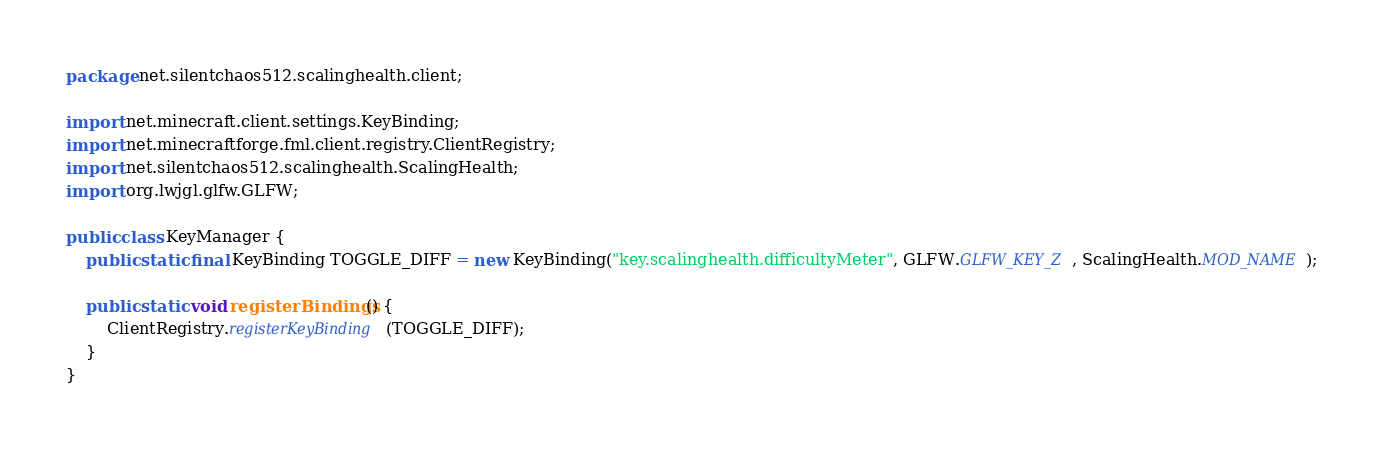Convert code to text. <code><loc_0><loc_0><loc_500><loc_500><_Java_>package net.silentchaos512.scalinghealth.client;

import net.minecraft.client.settings.KeyBinding;
import net.minecraftforge.fml.client.registry.ClientRegistry;
import net.silentchaos512.scalinghealth.ScalingHealth;
import org.lwjgl.glfw.GLFW;

public class KeyManager {
    public static final KeyBinding TOGGLE_DIFF = new KeyBinding("key.scalinghealth.difficultyMeter", GLFW.GLFW_KEY_Z, ScalingHealth.MOD_NAME);

    public static void registerBindings() {
        ClientRegistry.registerKeyBinding(TOGGLE_DIFF);
    }
}
</code> 